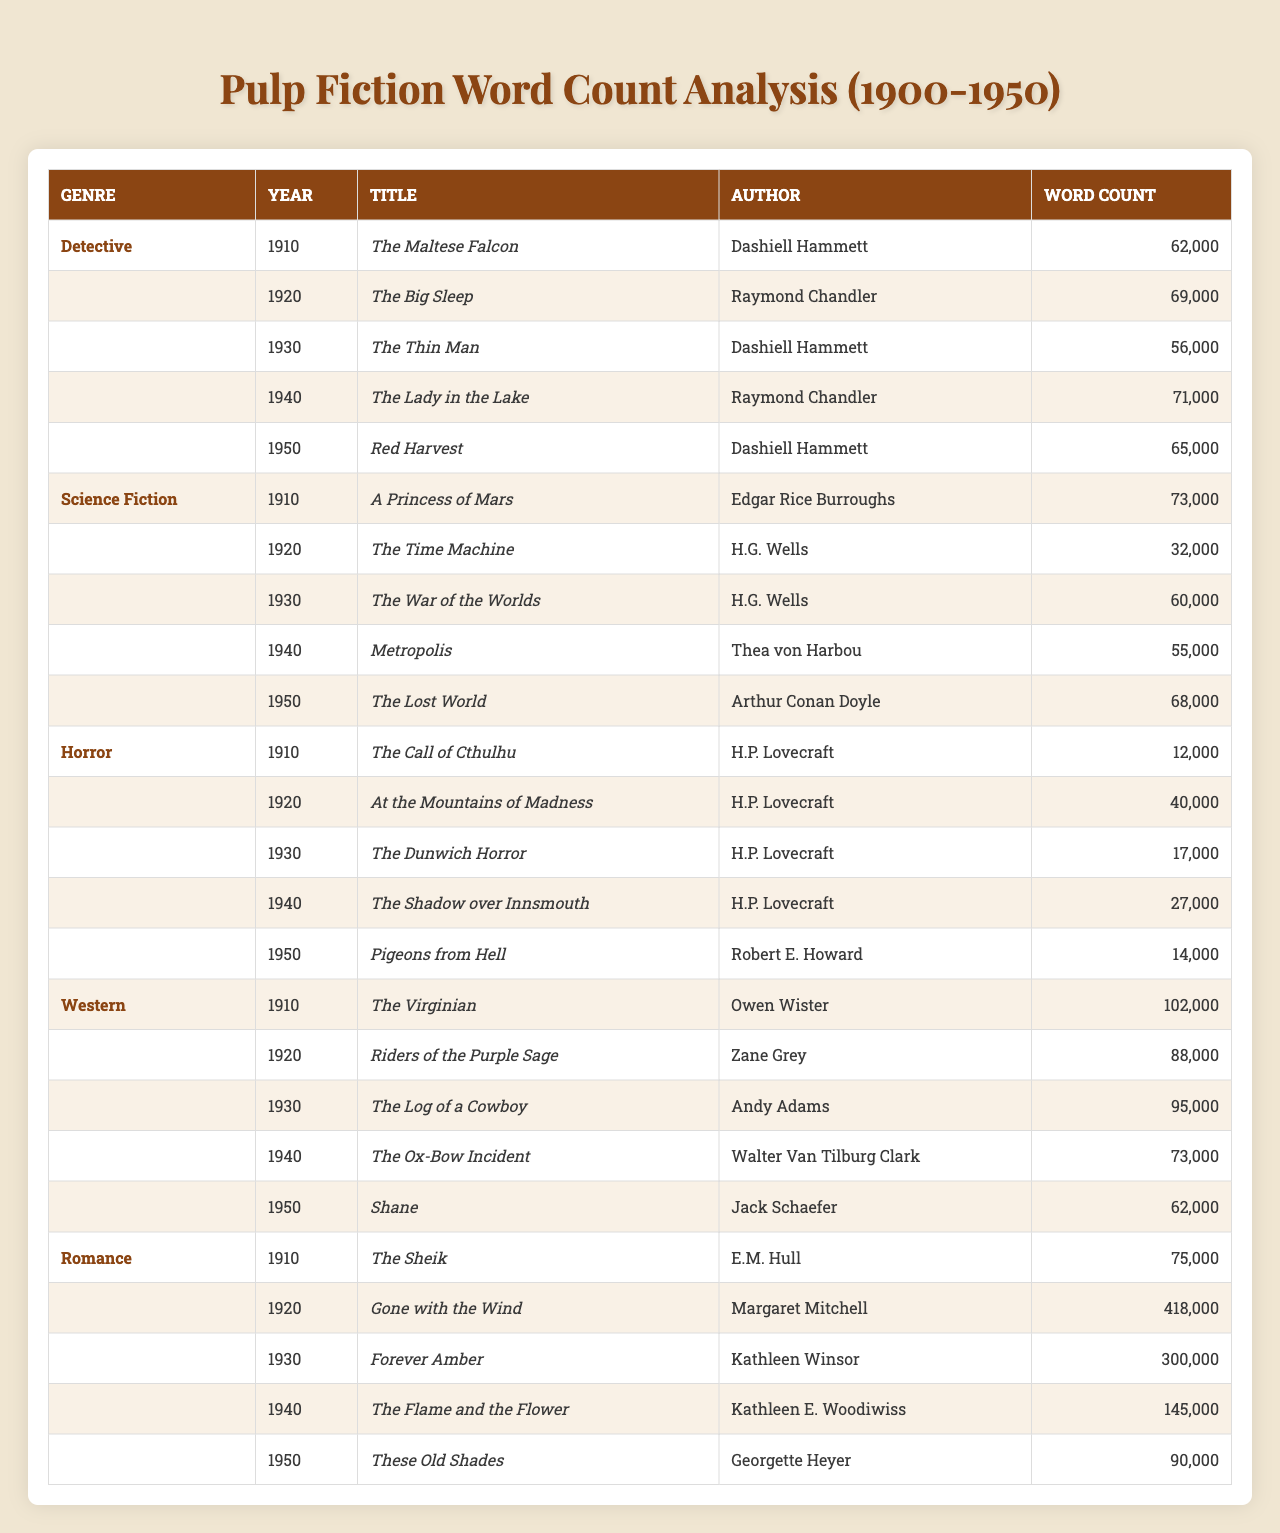What is the title with the highest word count in the Western genre? The highest word count in the Western genre is 102,000, which corresponds to the title "The Virginian" by Owen Wister.
Answer: The Virginian How many words does "Gone with the Wind" contain? The word count for "Gone with the Wind" is 418,000 words, as stated in the table under the Romance genre.
Answer: 418,000 Which author wrote the most works listed in the table? H.P. Lovecraft authored four stories listed in the table, corresponding to the Horror genre, making him the author with the most works.
Answer: H.P. Lovecraft What is the average word count of the Detective genre titles? The sum of word counts in the Detective genre is 62,000 + 69,000 + 56,000 + 71,000 + 65,000 = 323,000. With 5 titles, the average is 323,000 / 5 = 64,600.
Answer: 64,600 Is "The Time Machine" longer than "The War of the Worlds"? "The Time Machine" has a word count of 32,000, while "The War of the Worlds" has 60,000. Therefore, "The Time Machine" is not longer.
Answer: No What is the total word count of all titles in the Science Fiction genre? The total word count is calculated by adding each title in the Science Fiction genre: 73,000 + 32,000 + 60,000 + 55,000 + 68,000 = 288,000.
Answer: 288,000 Which genre has the longest average word count? To find the genre with the longest average word count, we calculate: Detective = 64,600, Science Fiction = 57,600, Horror = 23,800, Western = 86,000, and Romance = 202,000. The highest average is 202,000 for Romance.
Answer: Romance Who is the author of the story with the lowest word count? The lowest word count is 12,000 for "The Call of Cthulhu," and it was authored by H.P. Lovecraft.
Answer: H.P. Lovecraft Which title in the Western genre has the lowest word count? In the Western genre, "Shane" has the lowest word count of 62,000 compared to the other titles listed.
Answer: Shane How many different genres are represented in the table? There are five different genres listed in the table: Detective, Science Fiction, Horror, Western, and Romance.
Answer: Five 